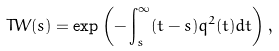Convert formula to latex. <formula><loc_0><loc_0><loc_500><loc_500>T W ( s ) = \exp \left ( - \int _ { s } ^ { \infty } ( t - s ) q ^ { 2 } ( t ) d t \right ) ,</formula> 